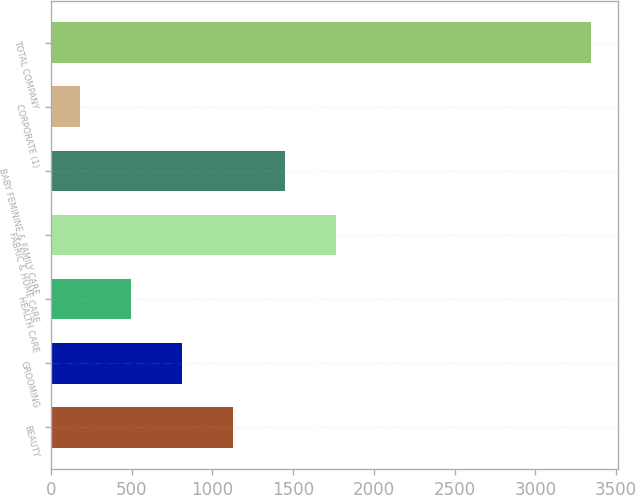<chart> <loc_0><loc_0><loc_500><loc_500><bar_chart><fcel>BEAUTY<fcel>GROOMING<fcel>HEALTH CARE<fcel>FABRIC & HOME CARE<fcel>BABY FEMININE & FAMILY CARE<fcel>CORPORATE (1)<fcel>TOTAL COMPANY<nl><fcel>1130.1<fcel>813.4<fcel>496.7<fcel>1763.5<fcel>1446.8<fcel>180<fcel>3347<nl></chart> 